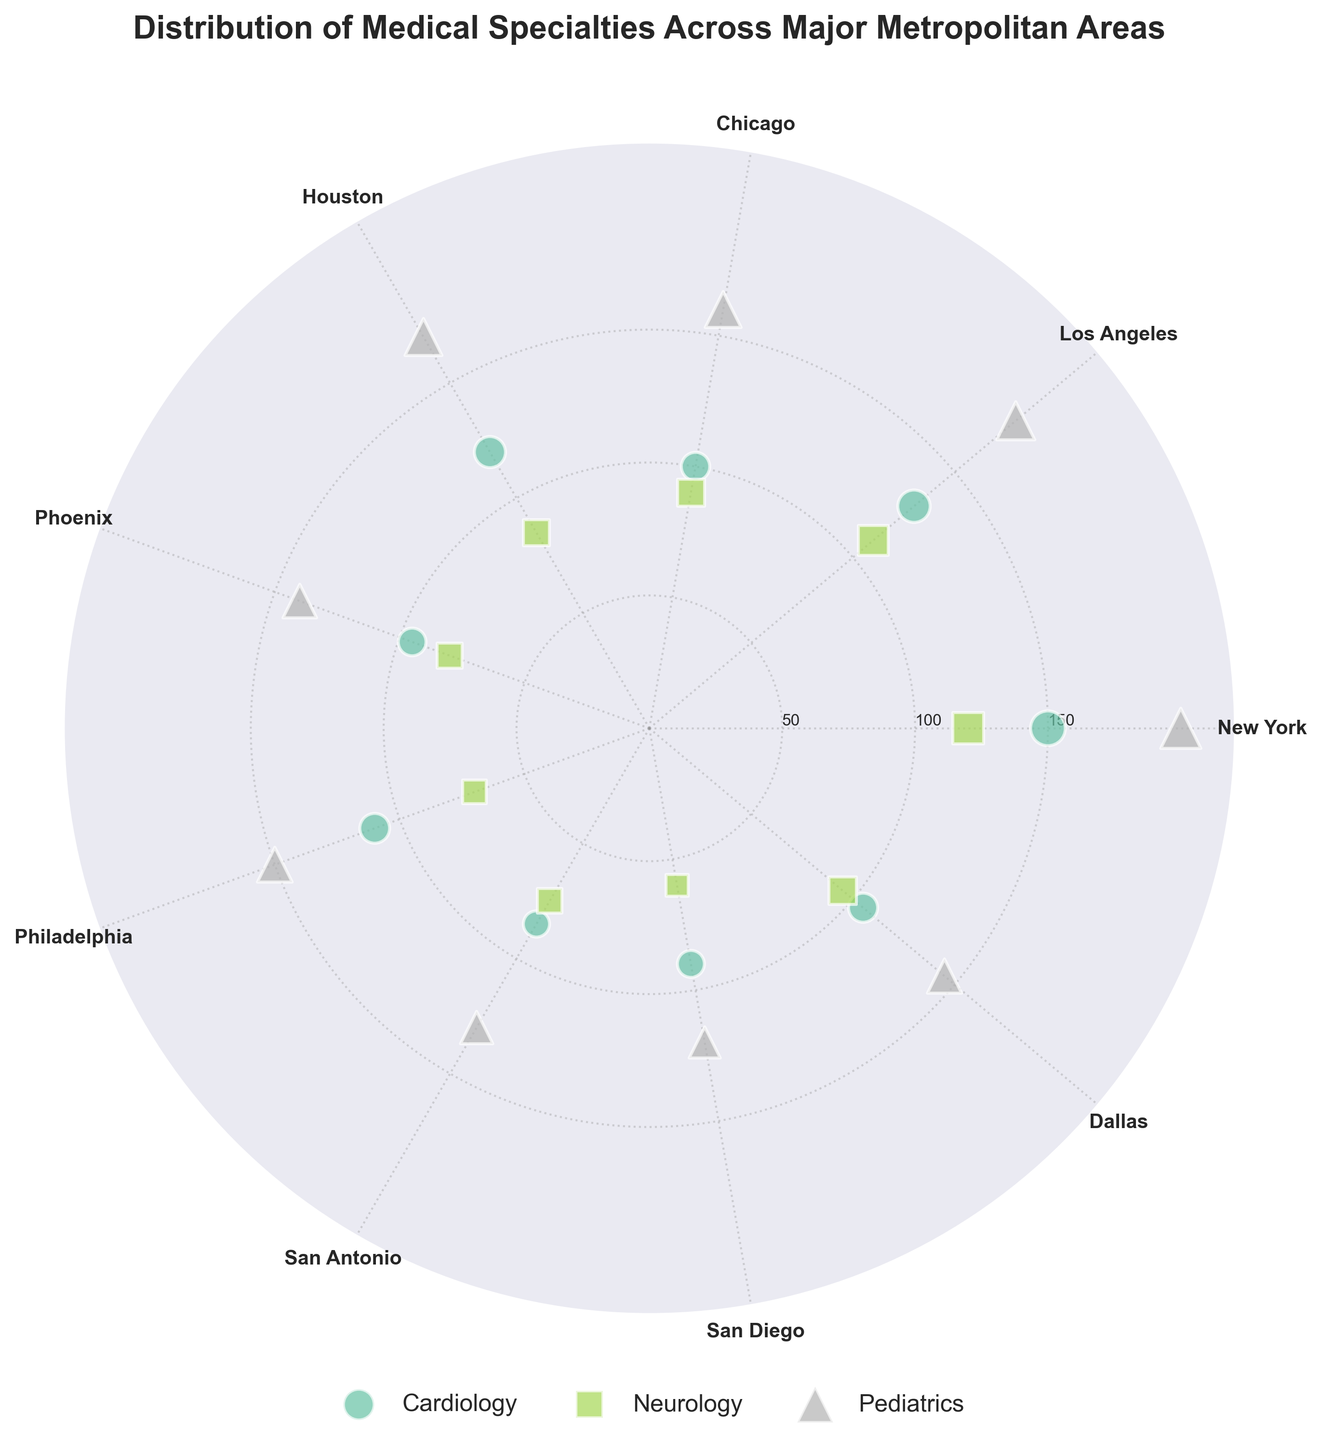What is the title of the figure? The title of the figure is generally positioned at the top, centered above the plot. In this case, it is prominently displayed and reads "Distribution of Medical Specialties Across Major Metropolitan Areas".
Answer: Distribution of Medical Specialties Across Major Metropolitan Areas Which city has the most pediatric specialists? To find this, look for the pediatric data points, which should be indicated by a specific color and marker type, and identify the city with the largest radial distance. The largest value is in New York.
Answer: New York What specialty has the least number of specialists in San Diego? Identify San Diego markers on the polar plot and compare the radial distances for each specialty. The smallest distance correlates to Neurology.
Answer: Neurology How many cities have over 100 specialists in Cardiology? Count the number of cities where the radial distances for Cardiology markers exceed the 100 mark on the radial axis. The cities are New York, Los Angeles, Philadelphia, Dallas, and Houston.
Answer: 5 Which specialty is most evenly distributed across all cities? Compare the radial distances for each specialty across all cities to see which one shows the least variation. Pediatrics markers show relatively consistent distances across the cities.
Answer: Pediatrics What is the difference in the number of Neurology specialists between New York and Chicago? Find the radial distances of Neurology markers for both New York and Chicago. New York has 120 and Chicago has 90, so the difference is 120 - 90 = 30.
Answer: 30 Which city has the highest average number of specialists across all specialties? Calculate the average number of specialists for each city by summing the radial distances of all specialties and dividing by three (the number of specialties). New York has the highest average.
Answer: New York Are there any cities where all specialties have fewer than 100 specialists? Compare the radial distances for all specialties in each city to see if any city has all data points below 100. San Diego and San Antonio meet this criterion.
Answer: San Diego, San Antonio In which city do Cardiology and Neurology specialists combined exceed the number of Pediatrics specialists? Look for cities where the sum of Cardiology and Neurology markers' radial distances is greater than that of the Pediatrics marker. In none of the displayed cities does this condition hold.
Answer: None How does the number of Pediatrics specialists in Phoenix compare to those in Dallas? Compare the radial distances for the Pediatrics markers in both Phoenix and Dallas. Pediatrics specialists in Dallas (145) outnumber those in Phoenix (140).
Answer: Dallas 